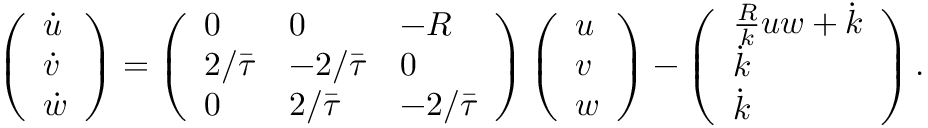Convert formula to latex. <formula><loc_0><loc_0><loc_500><loc_500>\left ( \begin{array} { l } { \dot { u } } \\ { \dot { v } } \\ { \dot { w } } \end{array} \right ) = \left ( \begin{array} { l l l } { 0 } & { 0 } & { - R } \\ { 2 / \bar { \tau } } & { - 2 / \bar { \tau } } & { 0 } \\ { 0 } & { 2 / \bar { \tau } } & { - 2 / \bar { \tau } } \end{array} \right ) \left ( \begin{array} { l } { u } \\ { v } \\ { w } \end{array} \right ) - \left ( \begin{array} { l } { \frac { R } { k } u w + \dot { k } } \\ { \dot { k } } \\ { \dot { k } } \end{array} \right ) .</formula> 